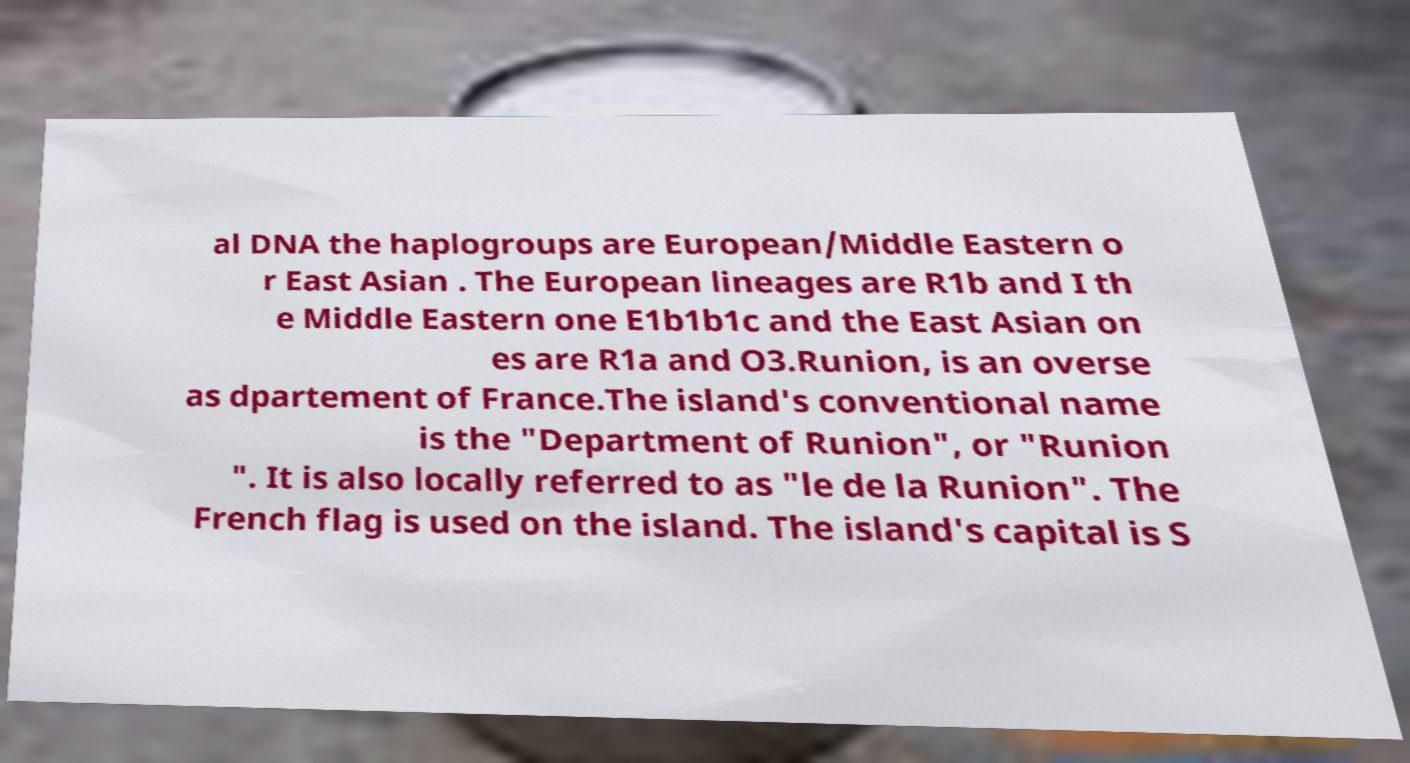Can you accurately transcribe the text from the provided image for me? al DNA the haplogroups are European/Middle Eastern o r East Asian . The European lineages are R1b and I th e Middle Eastern one E1b1b1c and the East Asian on es are R1a and O3.Runion, is an overse as dpartement of France.The island's conventional name is the "Department of Runion", or "Runion ". It is also locally referred to as "le de la Runion". The French flag is used on the island. The island's capital is S 